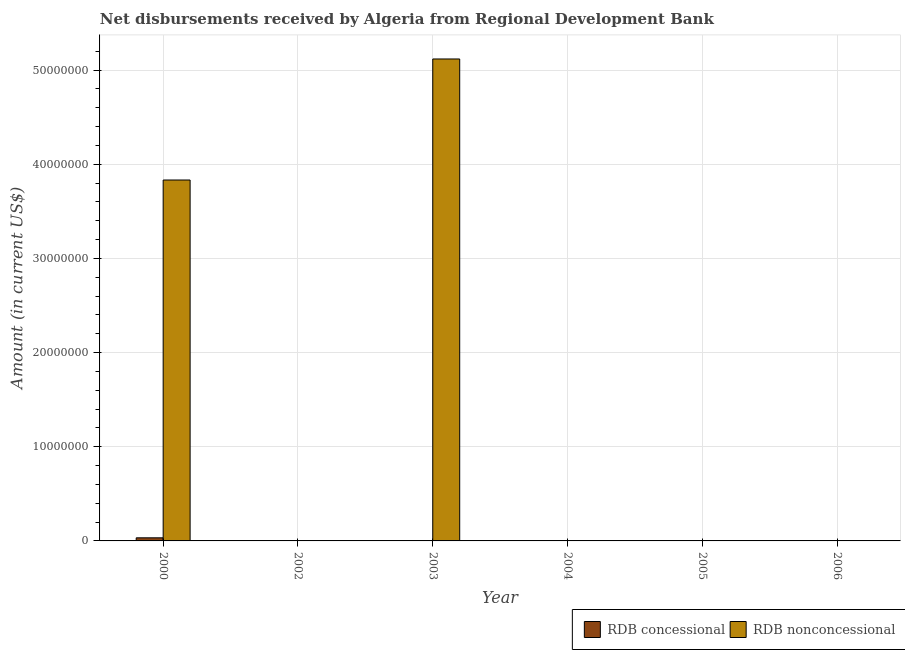How many different coloured bars are there?
Give a very brief answer. 2. Across all years, what is the maximum net non concessional disbursements from rdb?
Your answer should be very brief. 5.12e+07. Across all years, what is the minimum net non concessional disbursements from rdb?
Ensure brevity in your answer.  0. In which year was the net concessional disbursements from rdb maximum?
Make the answer very short. 2000. What is the total net concessional disbursements from rdb in the graph?
Your answer should be very brief. 3.30e+05. What is the difference between the net concessional disbursements from rdb in 2005 and the net non concessional disbursements from rdb in 2002?
Your answer should be compact. 0. What is the average net non concessional disbursements from rdb per year?
Your answer should be very brief. 1.49e+07. In the year 2003, what is the difference between the net non concessional disbursements from rdb and net concessional disbursements from rdb?
Your answer should be compact. 0. In how many years, is the net concessional disbursements from rdb greater than 14000000 US$?
Your answer should be very brief. 0. What is the difference between the highest and the lowest net concessional disbursements from rdb?
Keep it short and to the point. 3.30e+05. In how many years, is the net concessional disbursements from rdb greater than the average net concessional disbursements from rdb taken over all years?
Offer a terse response. 1. Is the sum of the net non concessional disbursements from rdb in 2000 and 2003 greater than the maximum net concessional disbursements from rdb across all years?
Make the answer very short. Yes. How many bars are there?
Keep it short and to the point. 3. Are all the bars in the graph horizontal?
Your answer should be compact. No. How many years are there in the graph?
Give a very brief answer. 6. How many legend labels are there?
Provide a short and direct response. 2. How are the legend labels stacked?
Make the answer very short. Horizontal. What is the title of the graph?
Offer a terse response. Net disbursements received by Algeria from Regional Development Bank. Does "Taxes on exports" appear as one of the legend labels in the graph?
Your answer should be very brief. No. What is the label or title of the X-axis?
Your response must be concise. Year. What is the Amount (in current US$) in RDB concessional in 2000?
Provide a short and direct response. 3.30e+05. What is the Amount (in current US$) in RDB nonconcessional in 2000?
Give a very brief answer. 3.83e+07. What is the Amount (in current US$) in RDB nonconcessional in 2003?
Make the answer very short. 5.12e+07. What is the Amount (in current US$) in RDB nonconcessional in 2004?
Your response must be concise. 0. What is the Amount (in current US$) of RDB nonconcessional in 2005?
Your response must be concise. 0. What is the Amount (in current US$) of RDB nonconcessional in 2006?
Give a very brief answer. 0. Across all years, what is the maximum Amount (in current US$) of RDB concessional?
Provide a succinct answer. 3.30e+05. Across all years, what is the maximum Amount (in current US$) of RDB nonconcessional?
Your answer should be compact. 5.12e+07. What is the total Amount (in current US$) in RDB nonconcessional in the graph?
Offer a terse response. 8.95e+07. What is the difference between the Amount (in current US$) in RDB nonconcessional in 2000 and that in 2003?
Offer a very short reply. -1.29e+07. What is the difference between the Amount (in current US$) of RDB concessional in 2000 and the Amount (in current US$) of RDB nonconcessional in 2003?
Ensure brevity in your answer.  -5.09e+07. What is the average Amount (in current US$) in RDB concessional per year?
Give a very brief answer. 5.50e+04. What is the average Amount (in current US$) of RDB nonconcessional per year?
Your answer should be very brief. 1.49e+07. In the year 2000, what is the difference between the Amount (in current US$) in RDB concessional and Amount (in current US$) in RDB nonconcessional?
Your response must be concise. -3.80e+07. What is the ratio of the Amount (in current US$) of RDB nonconcessional in 2000 to that in 2003?
Provide a succinct answer. 0.75. What is the difference between the highest and the lowest Amount (in current US$) of RDB concessional?
Provide a short and direct response. 3.30e+05. What is the difference between the highest and the lowest Amount (in current US$) of RDB nonconcessional?
Give a very brief answer. 5.12e+07. 